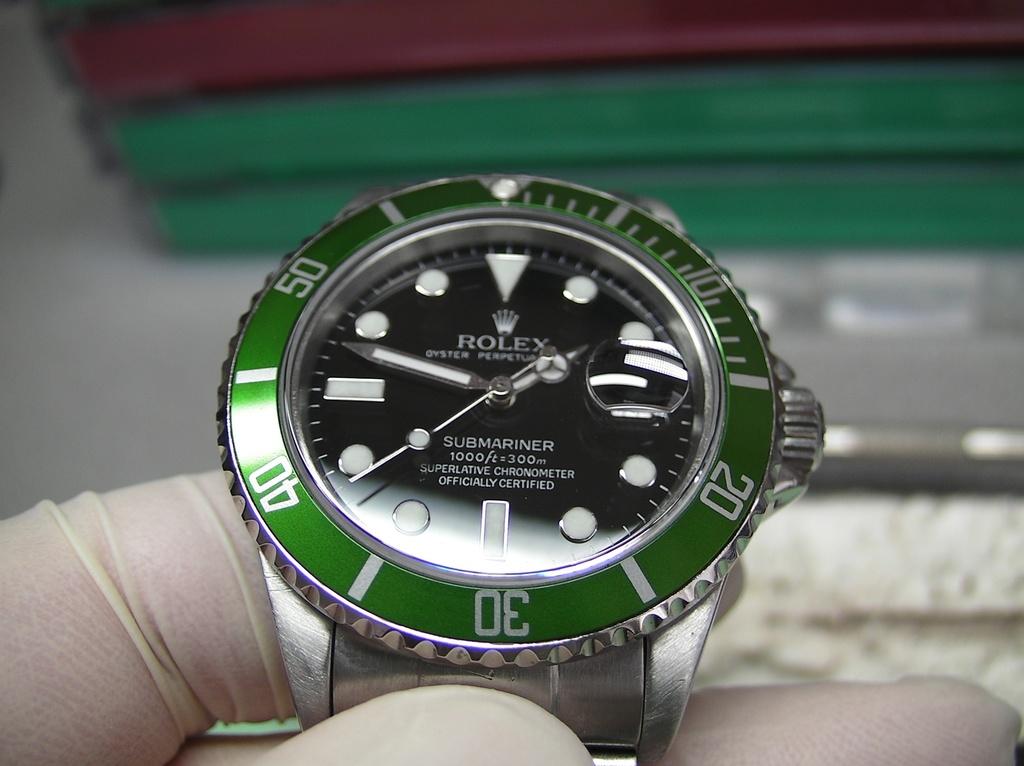What type of watch is this?
Give a very brief answer. Rolex. What is the highest number in the green around the watch face?
Offer a very short reply. 50. 